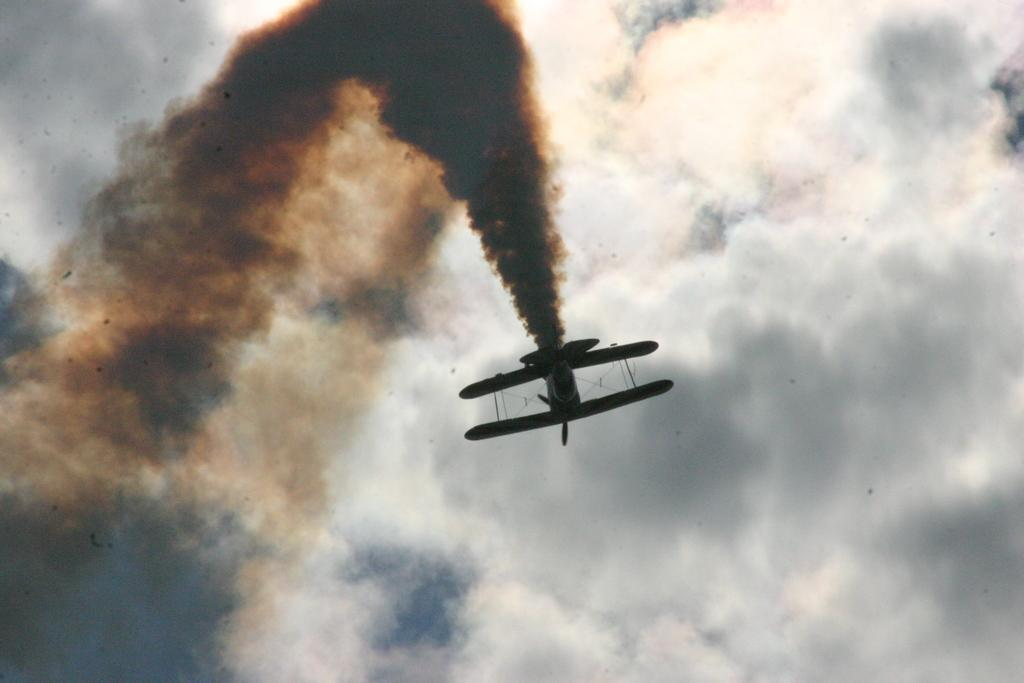What is the main subject of the image? The main subject of the image is a jet plane. What is the jet plane doing in the image? The jet plane is producing smoke in the image. What can be seen in the background of the image? The sky is visible in the image. How would you describe the weather based on the sky in the image? The sky appears to be cloudy in the image. What story is the father telling in the image? There is no father or story present in the image; it features a jet plane producing smoke against a cloudy sky. What type of spade is being used to dig in the image? There is no spade or digging activity present in the image. 